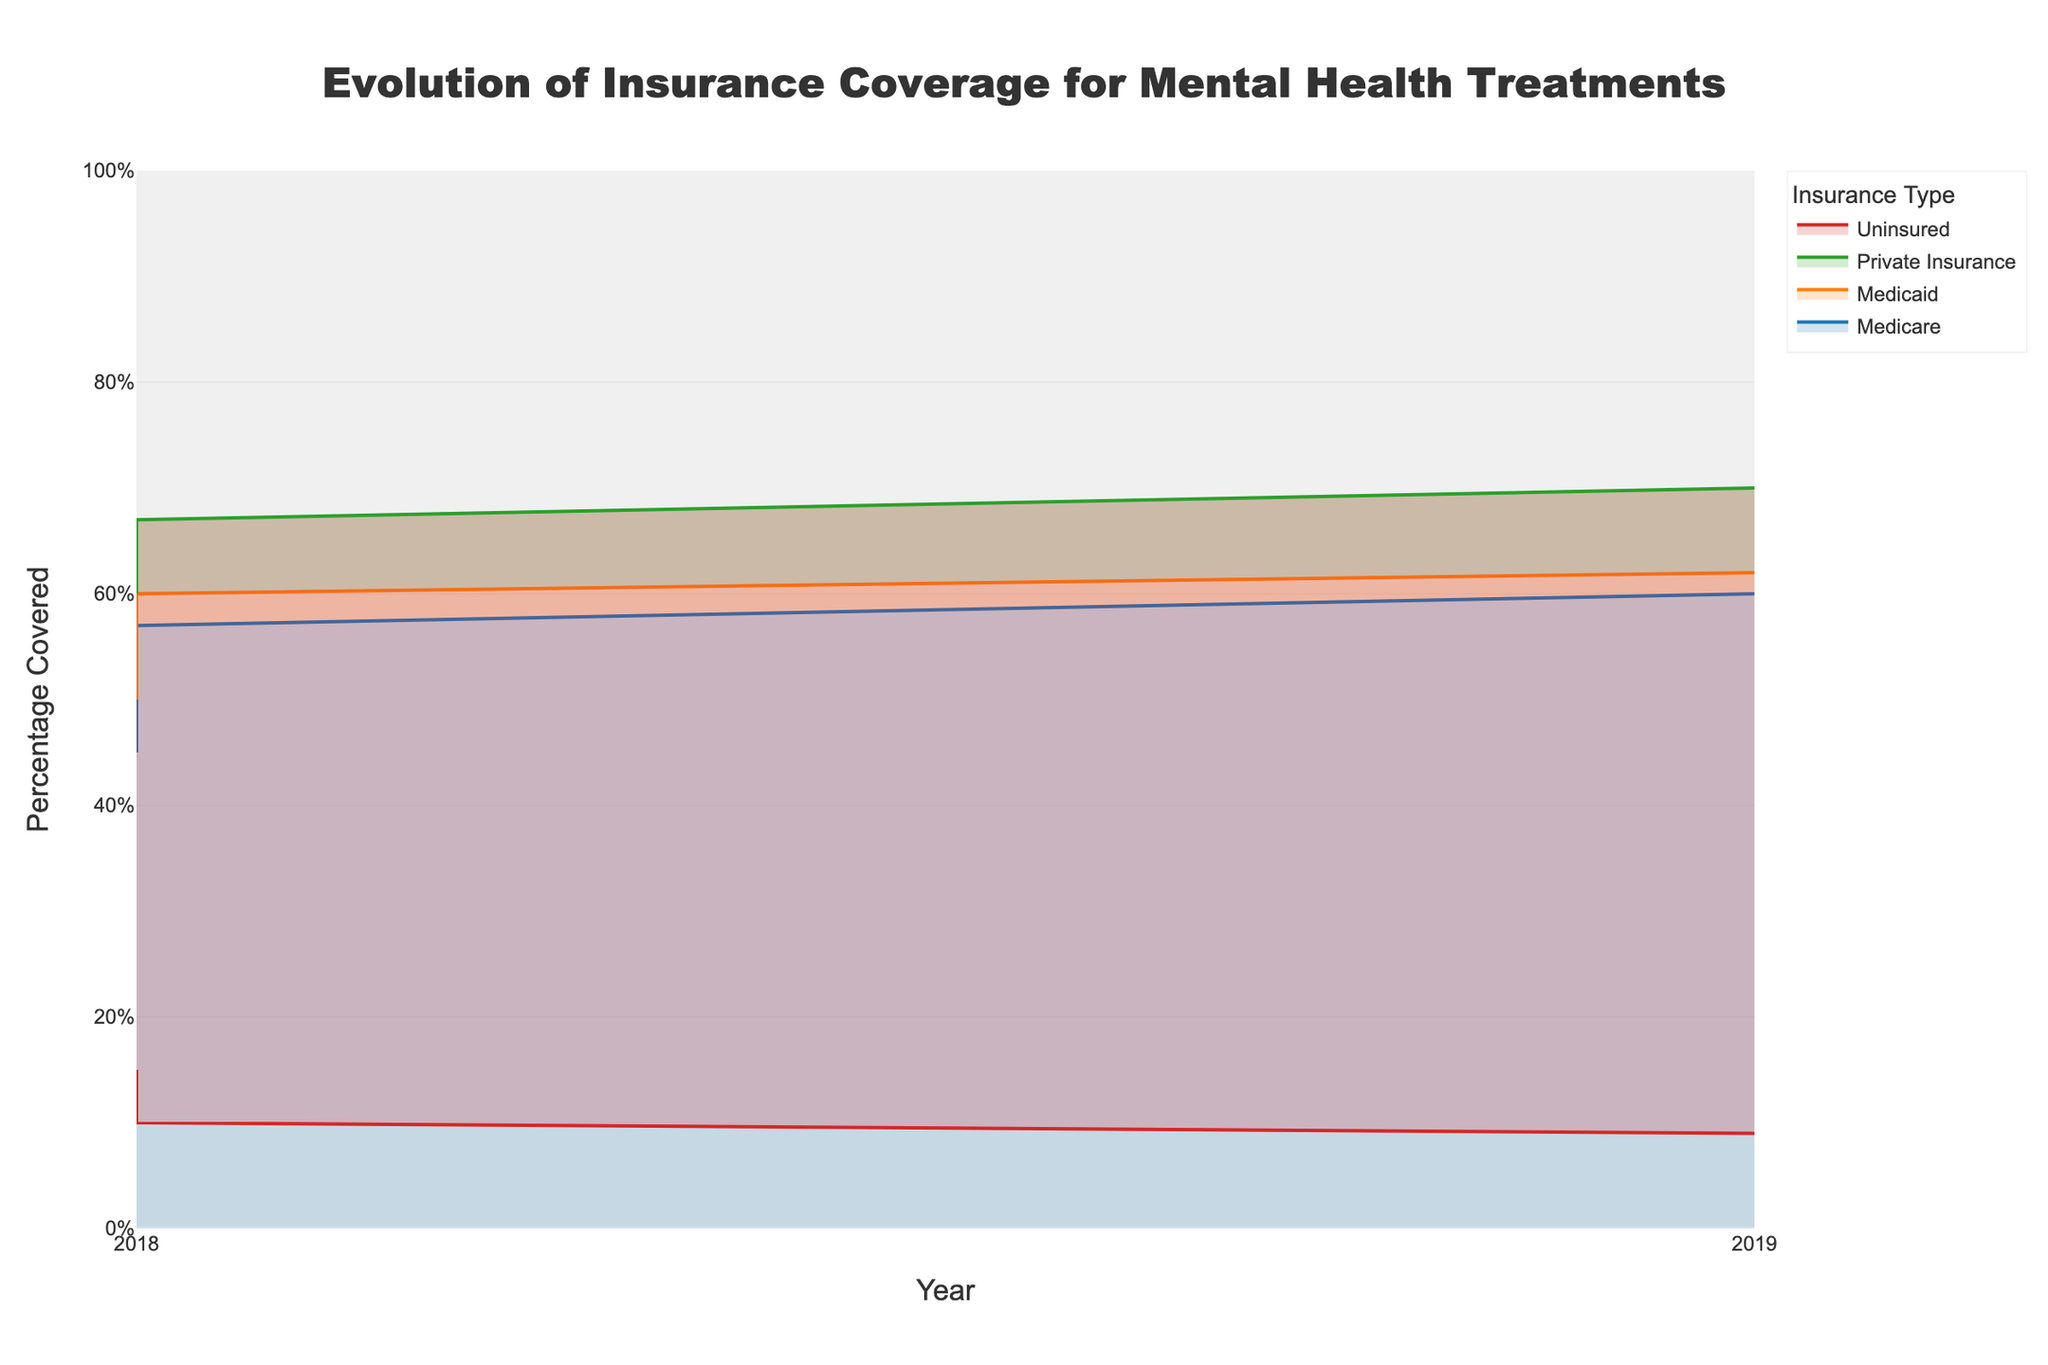What is the percentage of coverage provided by Medicare in 2022? Find the data point corresponding to Medicare in the year 2022 on the chart; the percentage covered is 60%.
Answer: 60% Which insurance type had the highest percentage coverage in 2020? Locate the data points for 2020 and compare the percentages for each insurance type; Private Insurance had the highest coverage at 65%.
Answer: Private Insurance How has the coverage for Uninsured changed from 2018 to 2022? Locate the data points for Uninsured for the years 2018 and 2022; the percentage changes from 15% in 2018 to 9% in 2022, showing a decrease.
Answer: Decreased What is the average percentage coverage for Private Insurance over the five years? Add all the percentage values of Private Insurance from 2018 to 2022 and divide by the number of years: (60 + 62 + 65 + 67 + 70) / 5 = 64.8.
Answer: 64.8% Compare the coverage trends of Medicare and Medicaid over the five years. Analyzing the chart, both Medicare and Medicaid show an increasing trend; Medicare rises from 45% in 2018 to 60% in 2022, and Medicaid from 50% in 2018 to 62% in 2022.
Answer: Both increased Which year saw the largest increase in Medicaid coverage? Compare the yearly changes for Medicaid from 2018 to 2022; the greatest increase is from 2018 to 2019 (50% to 55%), which is a 5% increase.
Answer: 2019 What is the sum of the percentages of Medicaid and Medicare coverage in 2021? Add the percentages for Medicare and Medicaid in 2021: Medicare (57%) + Medicaid (60%) = 117%.
Answer: 117% By how much did the percentage of coverage for Private Insurance increase from 2018 to 2022? Subtract the percentage in 2018 from the percentage in 2022 for Private Insurance: 70% - 60% = 10%.
Answer: 10% Which insurance type had the smallest change in coverage from 2018 to 2022? Calculate the change for each type by subtracting the 2018 percentage from the 2022 percentage; Uninsured had the smallest change of -6% (from 15% to 9%).
Answer: Uninsured 